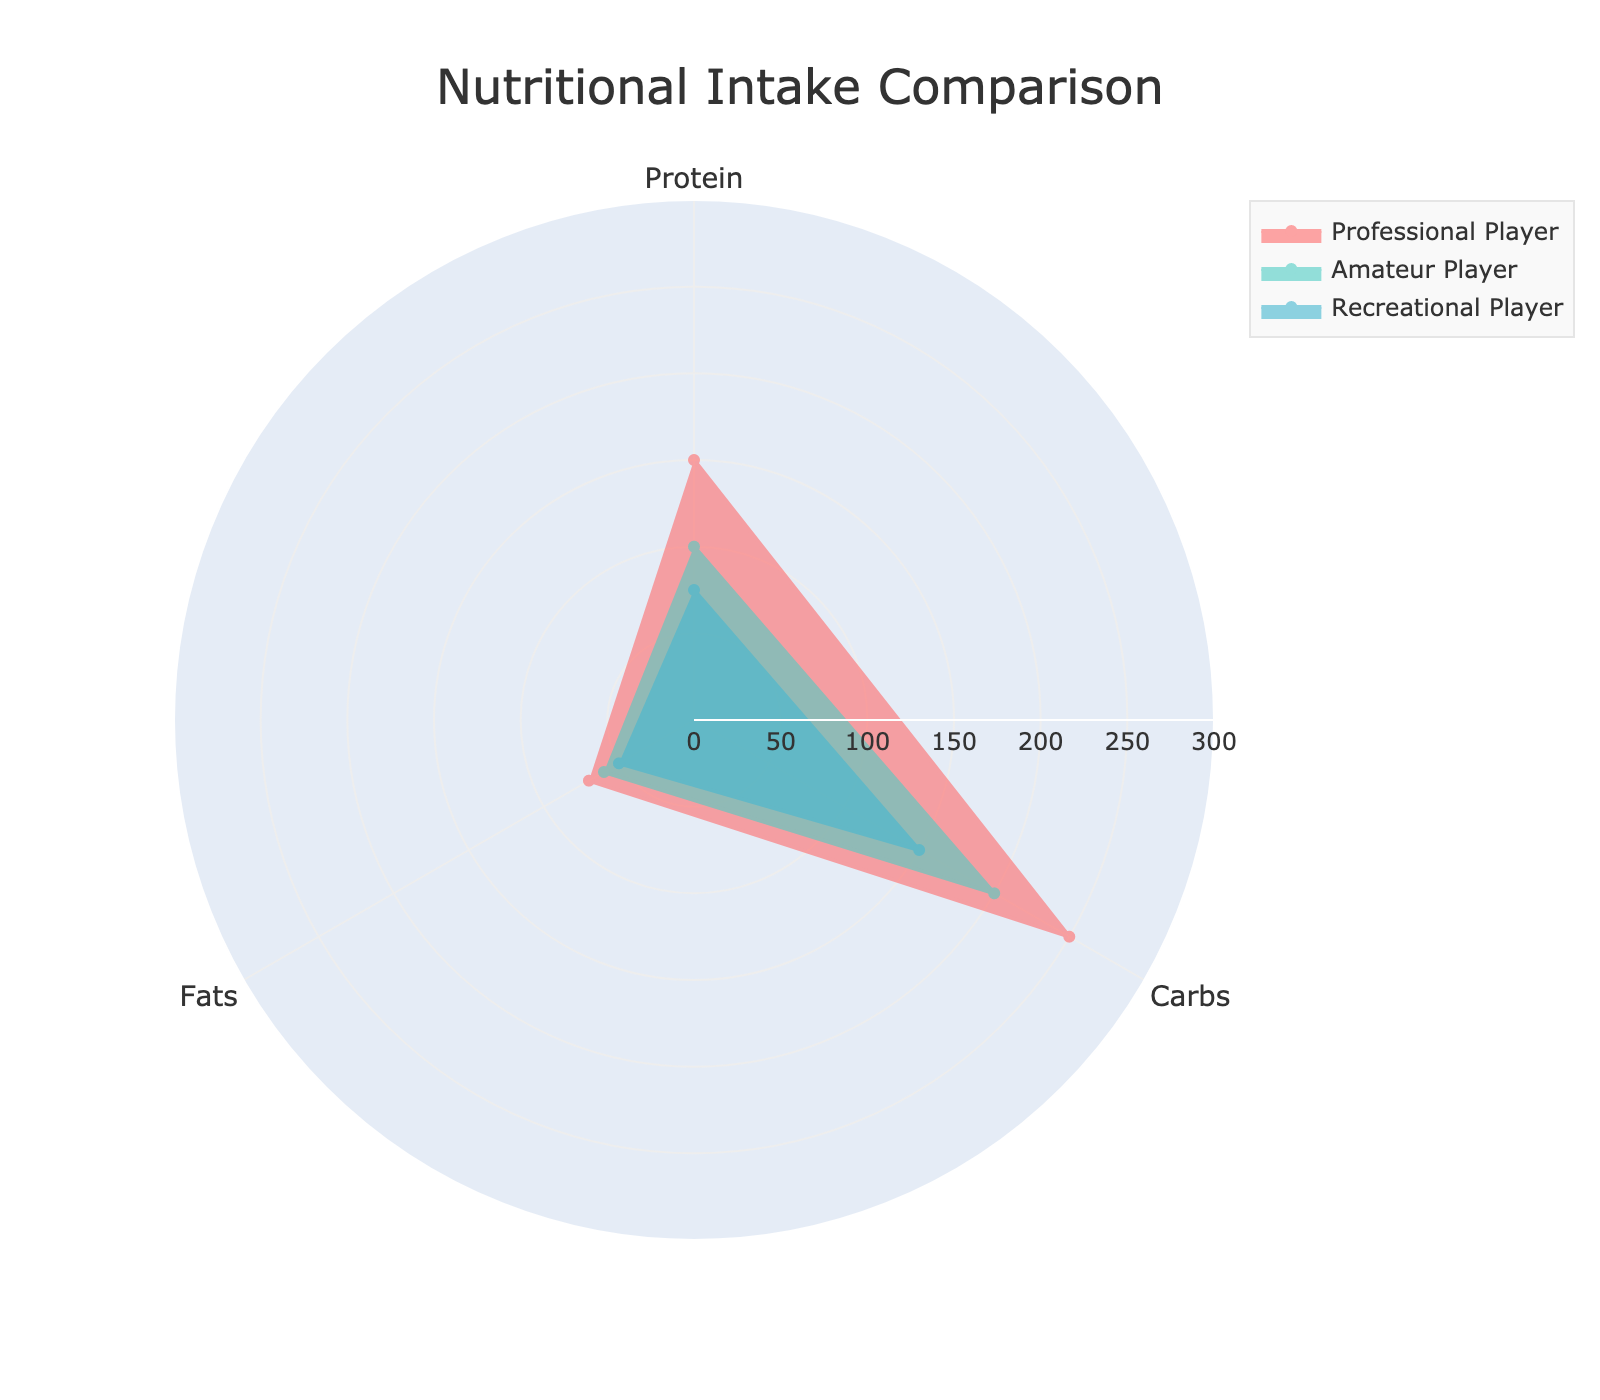How many groups are compared in the figure? The figure compares three groups: Professional Player, Amateur Player, and Recreational Player. This can be seen from the legend and the different colored areas on the radar chart representing each group.
Answer: Three What color represents Amateur Player? The Amateur Player group is represented by a greenish cyan color. This can be verified by checking the legend, where the colors corresponding to each group are clearly indicated.
Answer: Greenish cyan Which group consumes the most Protein? To determine this, observe the extent of the colored area on the radial axis for Protein. The Professional Player group reaches the highest value at the Protein point.
Answer: Professional Player How does the Carbs intake of an Average Person compare to that of a Recreational Player? The Carbs intake of an Average Person is shown around the 180 mark, whereas the Recreational Player has a Carbs intake of 150. Comparing the values from the chart, it's clear that an Average Person consumes more Carbs than a Recreational Player.
Answer: More What is the sum of the Protein intake for all three groups? To find this, sum the Protein intake for Professional Player (150), Amateur Player (100), and Recreational Player (75). This results in a total of 150 + 100 + 75 = 325.
Answer: 325 What is the difference in Fats intake between the Professional Player and the Recreational Player? The Fats intake for the Professional Player is 70, and for the Recreational Player, it's 50. The difference is calculated as 70 - 50 = 20.
Answer: 20 Which nutrient has the highest average intake across all groups? First, calculate the average intake for each nutrient across the three groups.
- Protein: (150 + 100 + 75) / 3 = 108.33
- Carbs: (250 + 200 + 150) / 3 = 200
- Fats: (70 + 60 + 50) / 3 = 60
Carbs has the highest average intake at 200.
Answer: Carbs Do any of the groups have the same Fats intake? Observing the Fats intake values, we see that the Professional Player and the Average Person both have an intake level at 70. This indicates that their Fats intakes are the same.
Answer: Yes What is the median Carbs intake value among the groups? The Carbs intake values for the groups are 250 (Professional Player), 200 (Amateur Player), and 150 (Recreational Player). Arranging these values in ascending order, we have [150, 200, 250]. The median value is the middle one, which is 200.
Answer: 200 Which group has the most balanced intake of the three nutrients? Examine the radar chart to see which group's plot forms a more regular shape or whose values for Protein, Carbs, and Fats are closer to each other. The Amateur Player's intake values are 100 (Protein), 200 (Carbs), and 60 (Fats), which is more balanced compared to other groups with more disparate values.
Answer: Amateur Player 